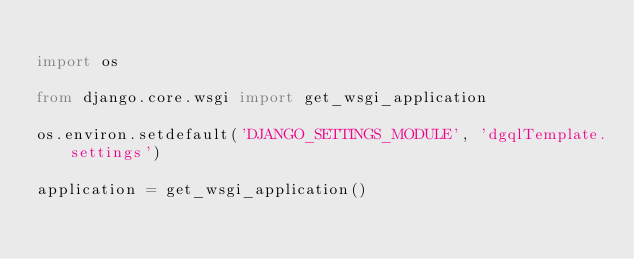Convert code to text. <code><loc_0><loc_0><loc_500><loc_500><_Python_>
import os

from django.core.wsgi import get_wsgi_application

os.environ.setdefault('DJANGO_SETTINGS_MODULE', 'dgqlTemplate.settings')

application = get_wsgi_application()
</code> 